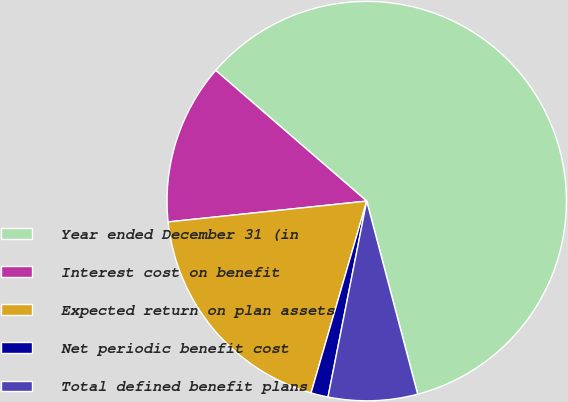Convert chart to OTSL. <chart><loc_0><loc_0><loc_500><loc_500><pie_chart><fcel>Year ended December 31 (in<fcel>Interest cost on benefit<fcel>Expected return on plan assets<fcel>Net periodic benefit cost<fcel>Total defined benefit plans<nl><fcel>59.54%<fcel>13.02%<fcel>18.84%<fcel>1.39%<fcel>7.21%<nl></chart> 